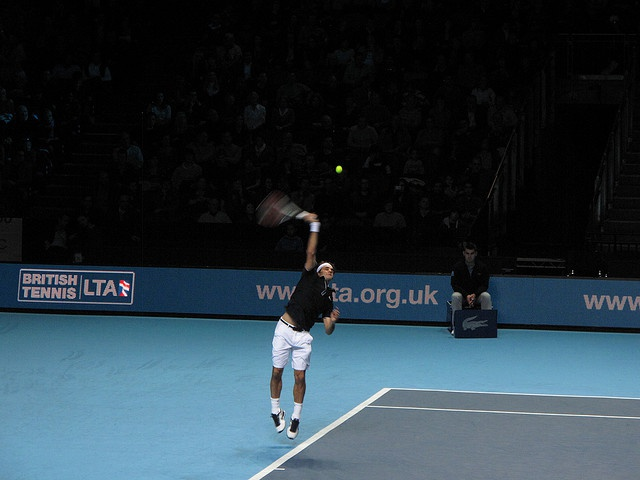Describe the objects in this image and their specific colors. I can see people in black, darkblue, and gray tones, people in black, lavender, and gray tones, people in black and darkblue tones, people in black, gray, darkblue, and purple tones, and tennis racket in black, gray, and darkgray tones in this image. 